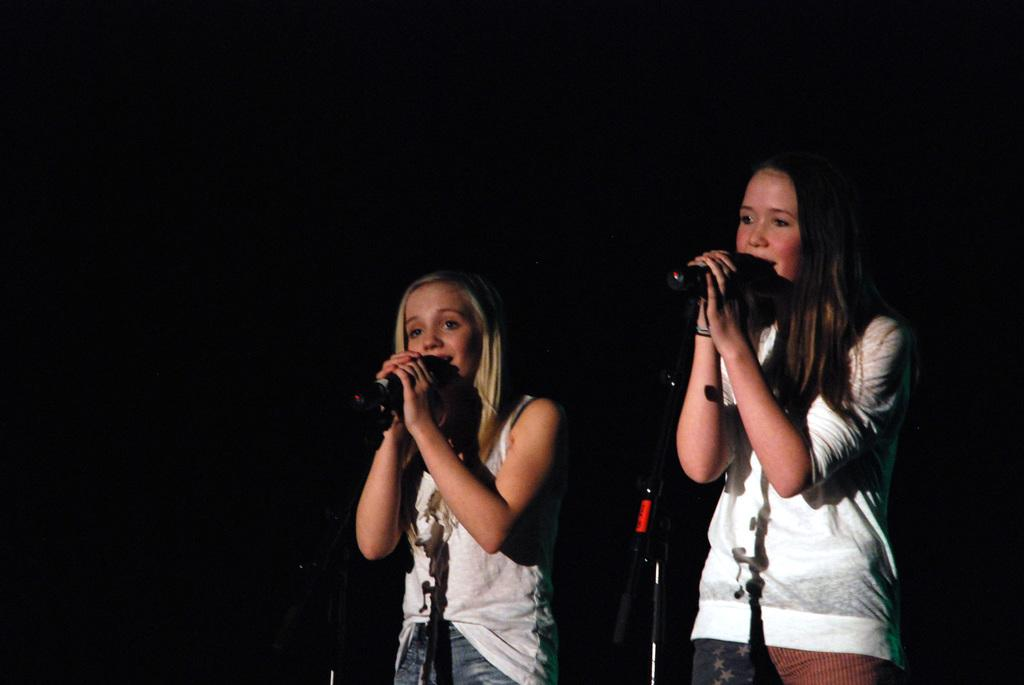How many people are in the image? There are two girls in the image. What are the girls doing in the image? The girls are standing and singing. What objects are present in the image that might be related to their activity? There are microphones in the image. What type of cup can be seen on the floor in the image? There is no cup present on the floor in the image. 